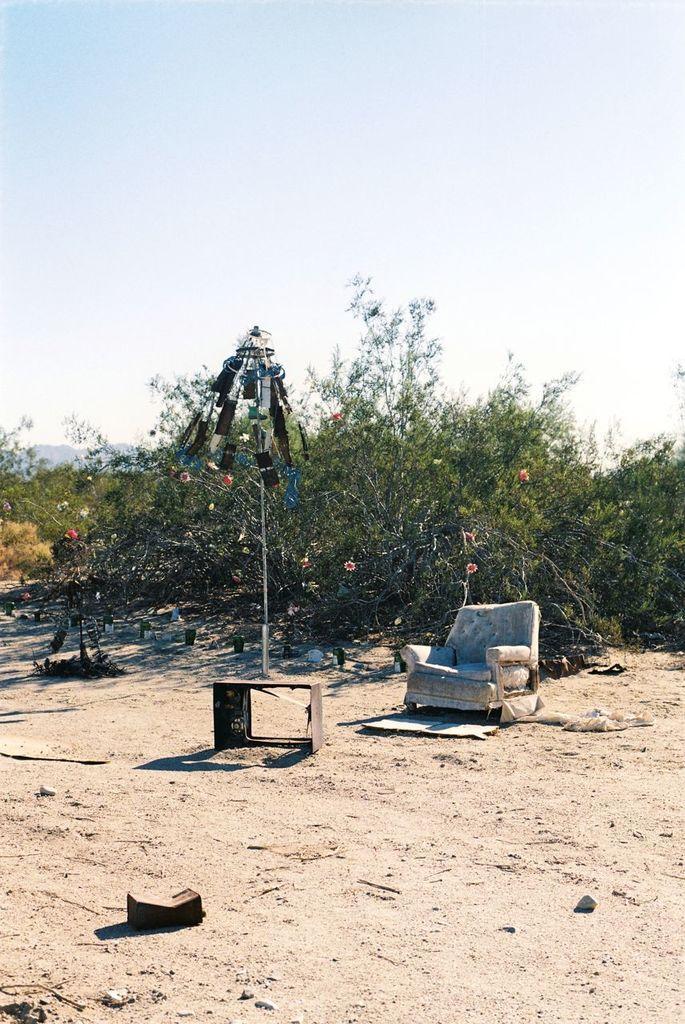In one or two sentences, can you explain what this image depicts? In this image I can see a chair and some objects on the ground. In the background I can see planets and the sky. 